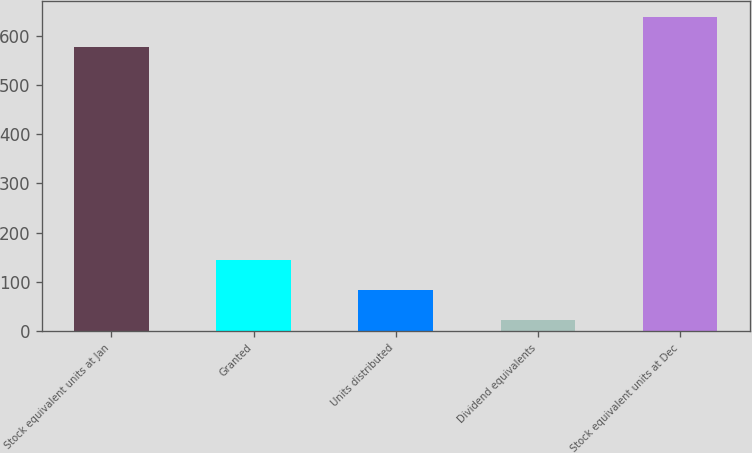Convert chart. <chart><loc_0><loc_0><loc_500><loc_500><bar_chart><fcel>Stock equivalent units at Jan<fcel>Granted<fcel>Units distributed<fcel>Dividend equivalents<fcel>Stock equivalent units at Dec<nl><fcel>577<fcel>144.8<fcel>83.4<fcel>22<fcel>638.4<nl></chart> 